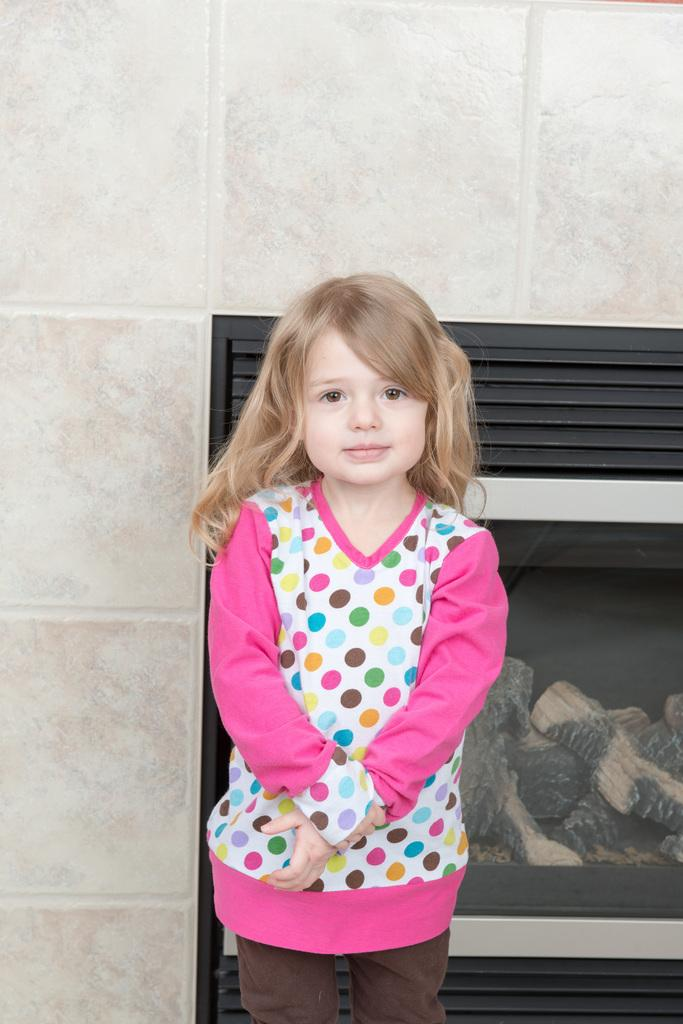What type of flooring is visible in the image? There are white color tiles in the image. What object can be seen in the image that might hold a picture or photograph? There is a photo frame in the image. Can you describe the woman in the image? The woman in the image is wearing a pink color dress and standing in the front of the image. What type of soup is the woman holding in the image? There is no soup present in the image; the woman is wearing a pink color dress and standing in front of a photo frame. What role does hope play in the image? The concept of hope is not present or depicted in the image. 